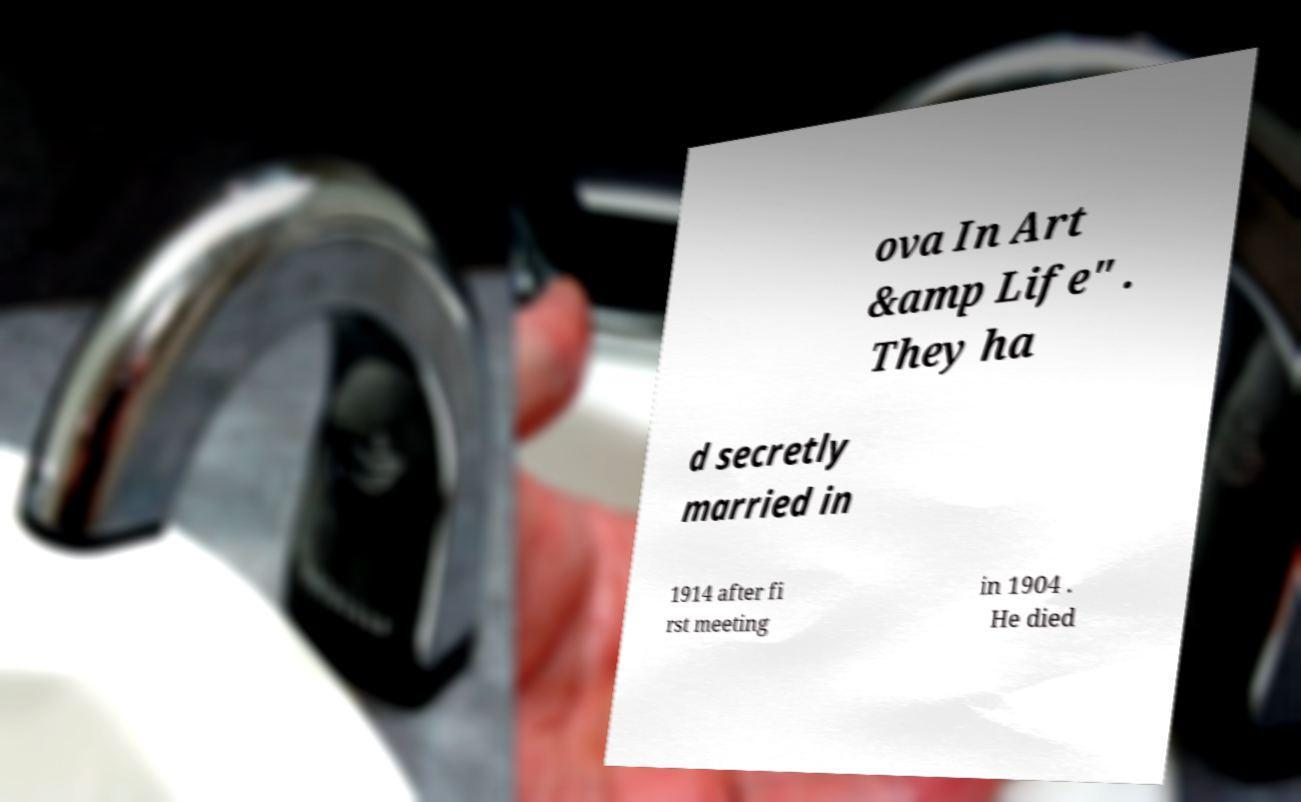Can you read and provide the text displayed in the image?This photo seems to have some interesting text. Can you extract and type it out for me? ova In Art &amp Life" . They ha d secretly married in 1914 after fi rst meeting in 1904 . He died 